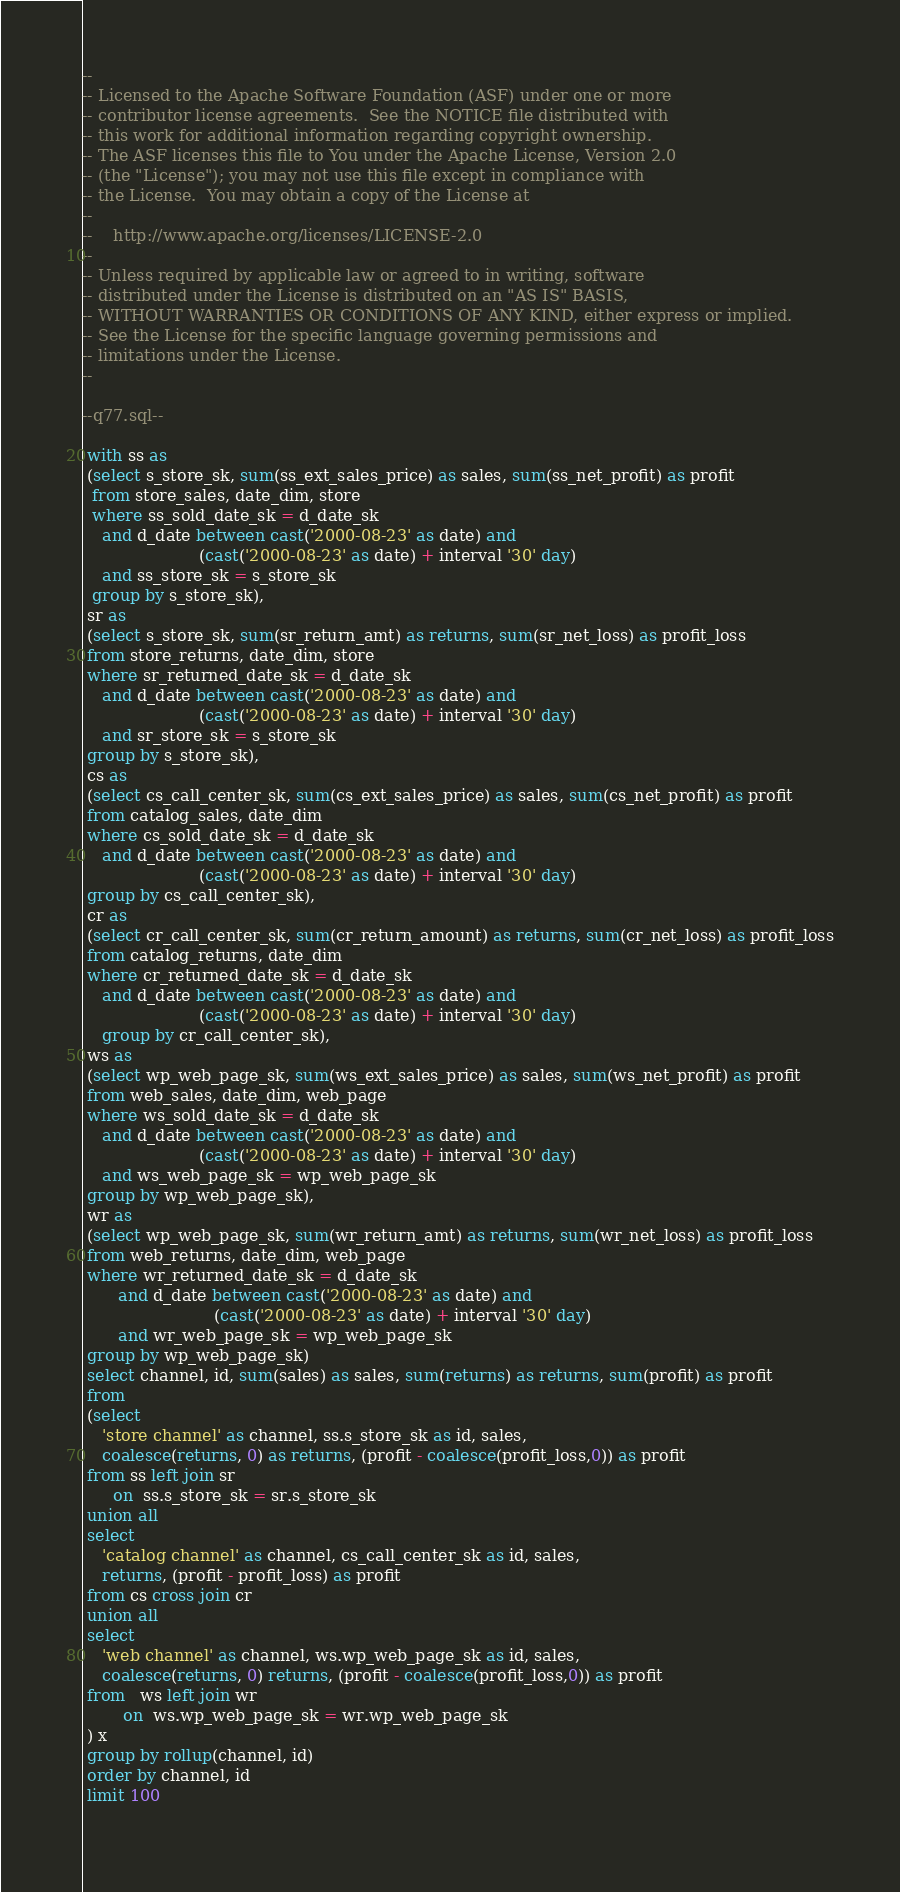Convert code to text. <code><loc_0><loc_0><loc_500><loc_500><_SQL_>--
-- Licensed to the Apache Software Foundation (ASF) under one or more
-- contributor license agreements.  See the NOTICE file distributed with
-- this work for additional information regarding copyright ownership.
-- The ASF licenses this file to You under the Apache License, Version 2.0
-- (the "License"); you may not use this file except in compliance with
-- the License.  You may obtain a copy of the License at
--
--    http://www.apache.org/licenses/LICENSE-2.0
--
-- Unless required by applicable law or agreed to in writing, software
-- distributed under the License is distributed on an "AS IS" BASIS,
-- WITHOUT WARRANTIES OR CONDITIONS OF ANY KIND, either express or implied.
-- See the License for the specific language governing permissions and
-- limitations under the License.
--

--q77.sql--

 with ss as
 (select s_store_sk, sum(ss_ext_sales_price) as sales, sum(ss_net_profit) as profit
  from store_sales, date_dim, store
  where ss_sold_date_sk = d_date_sk
    and d_date between cast('2000-08-23' as date) and
                       (cast('2000-08-23' as date) + interval '30' day)
    and ss_store_sk = s_store_sk
  group by s_store_sk),
 sr as
 (select s_store_sk, sum(sr_return_amt) as returns, sum(sr_net_loss) as profit_loss
 from store_returns, date_dim, store
 where sr_returned_date_sk = d_date_sk
    and d_date between cast('2000-08-23' as date) and
                       (cast('2000-08-23' as date) + interval '30' day)
    and sr_store_sk = s_store_sk
 group by s_store_sk),
 cs as
 (select cs_call_center_sk, sum(cs_ext_sales_price) as sales, sum(cs_net_profit) as profit
 from catalog_sales, date_dim
 where cs_sold_date_sk = d_date_sk
    and d_date between cast('2000-08-23' as date) and
                       (cast('2000-08-23' as date) + interval '30' day)
 group by cs_call_center_sk),
 cr as
 (select cr_call_center_sk, sum(cr_return_amount) as returns, sum(cr_net_loss) as profit_loss
 from catalog_returns, date_dim
 where cr_returned_date_sk = d_date_sk
    and d_date between cast('2000-08-23' as date) and
                       (cast('2000-08-23' as date) + interval '30' day)
	group by cr_call_center_sk),
 ws as
 (select wp_web_page_sk, sum(ws_ext_sales_price) as sales, sum(ws_net_profit) as profit
 from web_sales, date_dim, web_page
 where ws_sold_date_sk = d_date_sk
    and d_date between cast('2000-08-23' as date) and
                       (cast('2000-08-23' as date) + interval '30' day)
    and ws_web_page_sk = wp_web_page_sk
 group by wp_web_page_sk),
 wr as
 (select wp_web_page_sk, sum(wr_return_amt) as returns, sum(wr_net_loss) as profit_loss
 from web_returns, date_dim, web_page
 where wr_returned_date_sk = d_date_sk
       and d_date between cast('2000-08-23' as date) and
                          (cast('2000-08-23' as date) + interval '30' day)
       and wr_web_page_sk = wp_web_page_sk
 group by wp_web_page_sk)
 select channel, id, sum(sales) as sales, sum(returns) as returns, sum(profit) as profit
 from
 (select
    'store channel' as channel, ss.s_store_sk as id, sales,
    coalesce(returns, 0) as returns, (profit - coalesce(profit_loss,0)) as profit
 from ss left join sr
      on  ss.s_store_sk = sr.s_store_sk
 union all
 select
    'catalog channel' as channel, cs_call_center_sk as id, sales,
    returns, (profit - profit_loss) as profit
 from cs cross join cr
 union all
 select
    'web channel' as channel, ws.wp_web_page_sk as id, sales,
    coalesce(returns, 0) returns, (profit - coalesce(profit_loss,0)) as profit
 from   ws left join wr
        on  ws.wp_web_page_sk = wr.wp_web_page_sk
 ) x
 group by rollup(channel, id)
 order by channel, id
 limit 100
            
</code> 